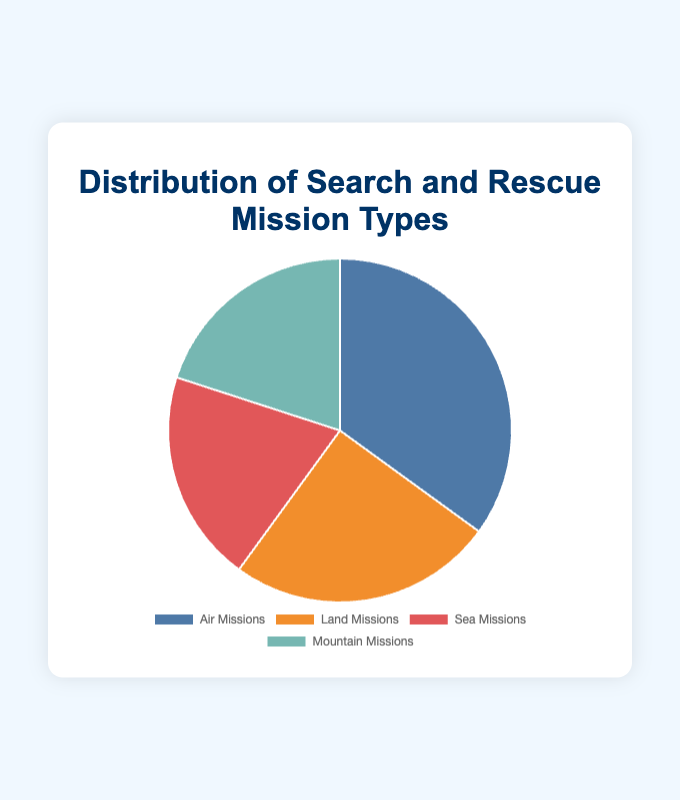What percentage of the missions are either Sea or Mountain missions? Sea missions make up 20% and Mountain missions make up 20%. Adding them gives 20% + 20% = 40%.
Answer: 40% Which type of mission is the most common? The Air missions have the highest percentage at 35%.
Answer: Air missions How does the number of Air missions compare to the combined number of Sea and Mountain missions? Air missions make up 35%, while Sea and Mountain missions combined make up 20% + 20% = 40%. 35% is less than 40%.
Answer: Less than What is the difference in the percentage between Air missions and Land missions? Air missions are 35%, Land missions are 25%. The difference is 35% - 25% = 10%.
Answer: 10% Which mission types have an equal percentage? Sea missions and Mountain missions both comprise 20%.
Answer: Sea missions and Mountain missions What is the total percentage of Air and Land missions combined? Air missions are 35% and Land missions are 25%. Adding them gives 35% + 25% = 60%.
Answer: 60% What is the average percentage of all mission types? The percentage values are 35, 25, 20, and 20. Summing them gives 35 + 25 + 20 + 20 = 100. Dividing by 4 (the number of types) gives 100 / 4 = 25%.
Answer: 25% If Sea missions were increased by 10%, what would their new percentage be? Current Sea missions are 20%, increasing by 10% would give 20% + 10% = 30%.
Answer: 30% Are there any mission types that make up one-fourth of the total percentage? One-fourth of 100% is 25%. Only Land missions match this percentage.
Answer: Land missions 